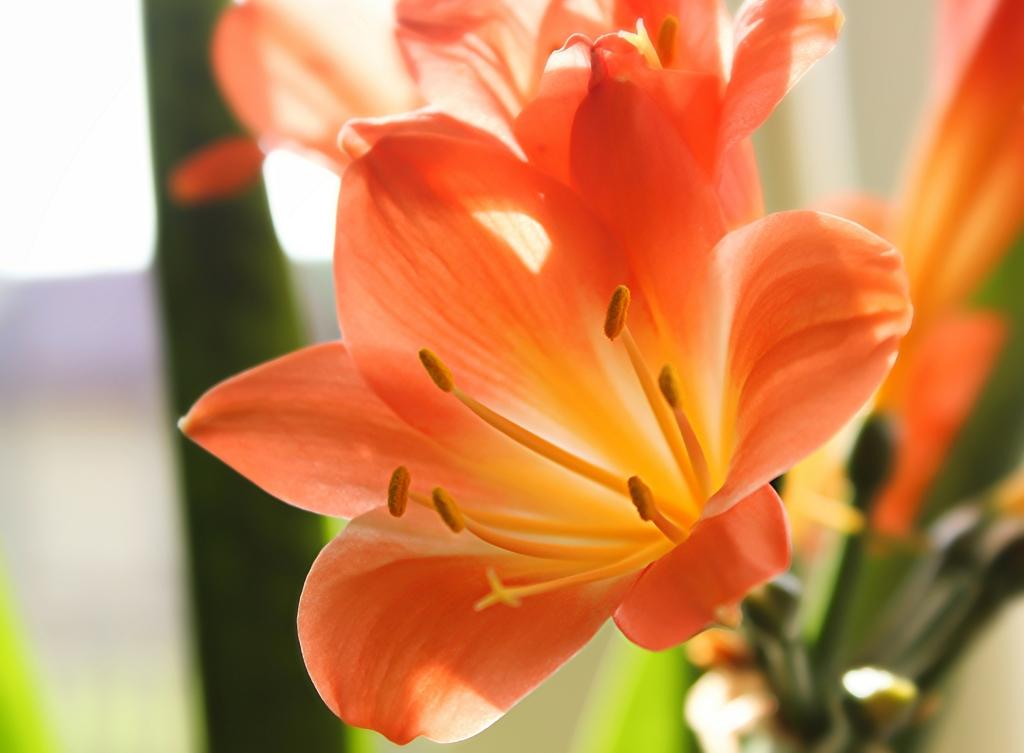What type of plants can be seen in the image? There are flowers in the image. Can you describe the background of the image? The background of the image is blurred. What type of stove is visible in the image? There is no stove present in the image; it features flowers and a blurred background. 